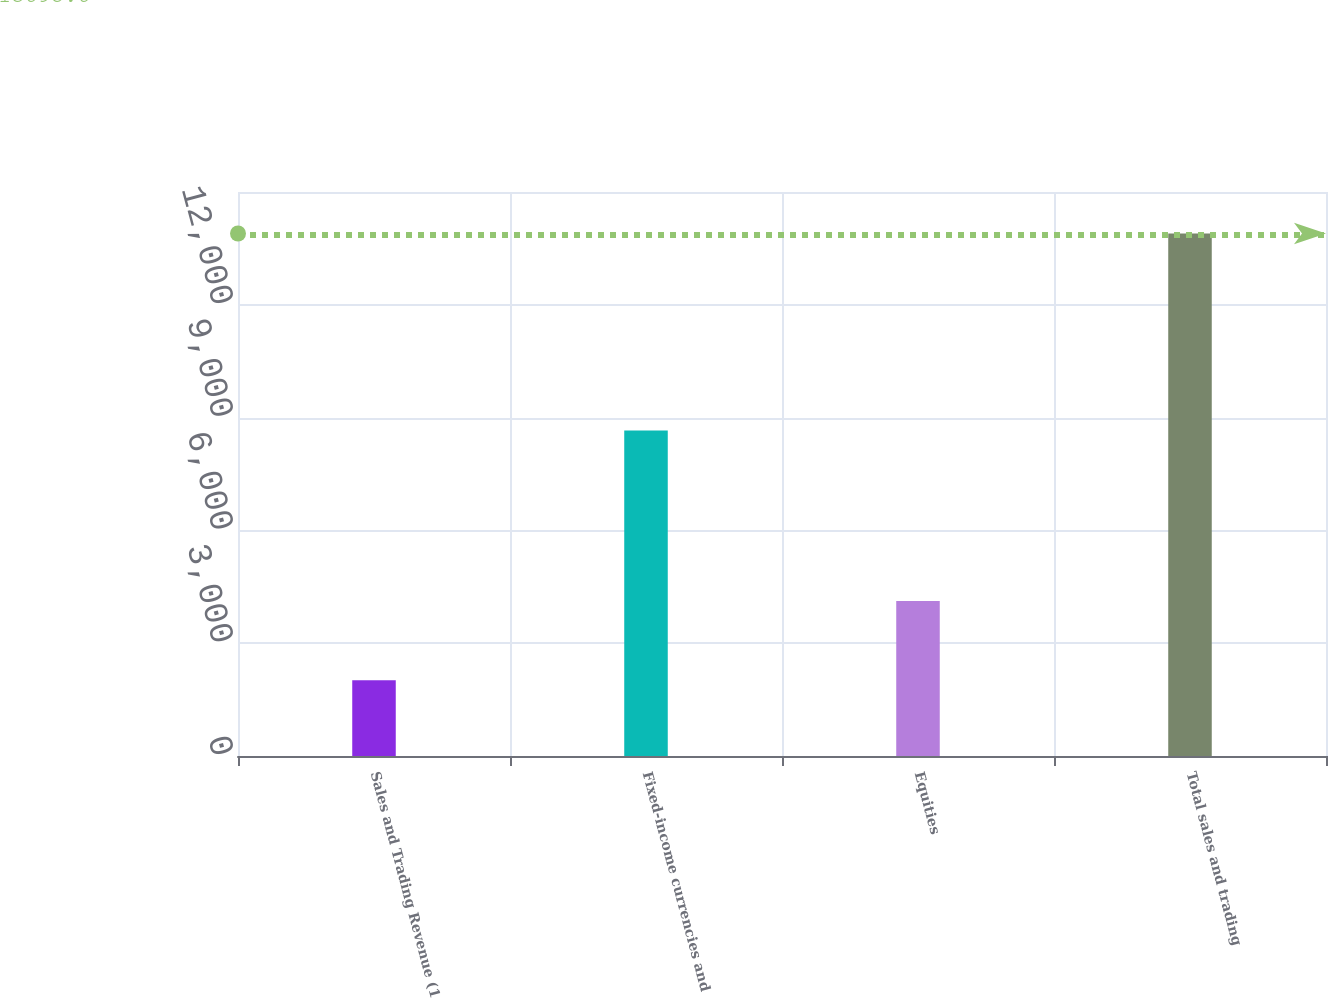Convert chart to OTSL. <chart><loc_0><loc_0><loc_500><loc_500><bar_chart><fcel>Sales and Trading Revenue (1<fcel>Fixed-income currencies and<fcel>Equities<fcel>Total sales and trading<nl><fcel>2017<fcel>8657<fcel>4120<fcel>13895.8<nl></chart> 